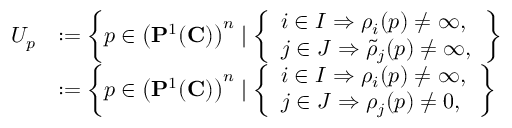<formula> <loc_0><loc_0><loc_500><loc_500>\begin{array} { r l } { U _ { p } } & { \colon = \left \{ p \in \left ( { P } ^ { 1 } ( { \mathbf C } ) \right ) ^ { n } | \left \{ \begin{array} { l l } { i \in I \Rightarrow \rho _ { i } ( p ) \neq \infty , } \\ { j \in J \Rightarrow \tilde { \rho } _ { j } ( p ) \neq \infty , } \end{array} \right \} } \\ & { \colon = \left \{ p \in \left ( { P } ^ { 1 } ( { \mathbf C } ) \right ) ^ { n } | \left \{ \begin{array} { l l } { i \in I \Rightarrow \rho _ { i } ( p ) \neq \infty , } \\ { j \in J \Rightarrow \rho _ { j } ( p ) \neq 0 , } \end{array} \right \} } \end{array}</formula> 